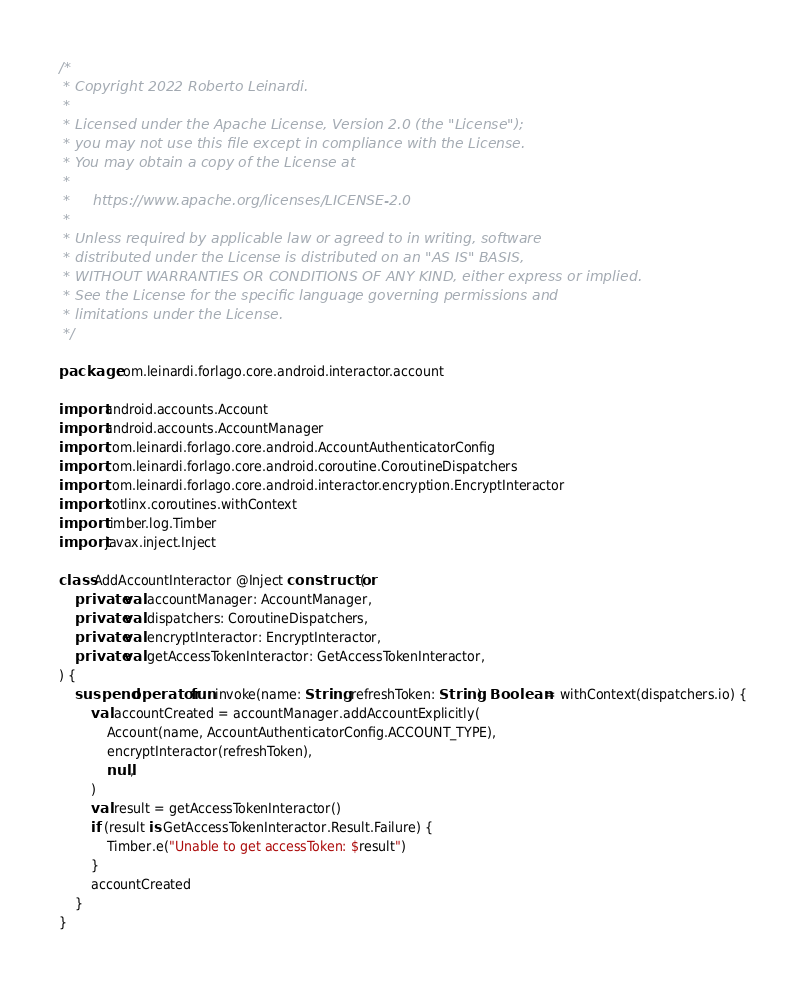<code> <loc_0><loc_0><loc_500><loc_500><_Kotlin_>/*
 * Copyright 2022 Roberto Leinardi.
 *
 * Licensed under the Apache License, Version 2.0 (the "License");
 * you may not use this file except in compliance with the License.
 * You may obtain a copy of the License at
 *
 *     https://www.apache.org/licenses/LICENSE-2.0
 *
 * Unless required by applicable law or agreed to in writing, software
 * distributed under the License is distributed on an "AS IS" BASIS,
 * WITHOUT WARRANTIES OR CONDITIONS OF ANY KIND, either express or implied.
 * See the License for the specific language governing permissions and
 * limitations under the License.
 */

package com.leinardi.forlago.core.android.interactor.account

import android.accounts.Account
import android.accounts.AccountManager
import com.leinardi.forlago.core.android.AccountAuthenticatorConfig
import com.leinardi.forlago.core.android.coroutine.CoroutineDispatchers
import com.leinardi.forlago.core.android.interactor.encryption.EncryptInteractor
import kotlinx.coroutines.withContext
import timber.log.Timber
import javax.inject.Inject

class AddAccountInteractor @Inject constructor(
    private val accountManager: AccountManager,
    private val dispatchers: CoroutineDispatchers,
    private val encryptInteractor: EncryptInteractor,
    private val getAccessTokenInteractor: GetAccessTokenInteractor,
) {
    suspend operator fun invoke(name: String, refreshToken: String): Boolean = withContext(dispatchers.io) {
        val accountCreated = accountManager.addAccountExplicitly(
            Account(name, AccountAuthenticatorConfig.ACCOUNT_TYPE),
            encryptInteractor(refreshToken),
            null,
        )
        val result = getAccessTokenInteractor()
        if (result is GetAccessTokenInteractor.Result.Failure) {
            Timber.e("Unable to get accessToken: $result")
        }
        accountCreated
    }
}
</code> 